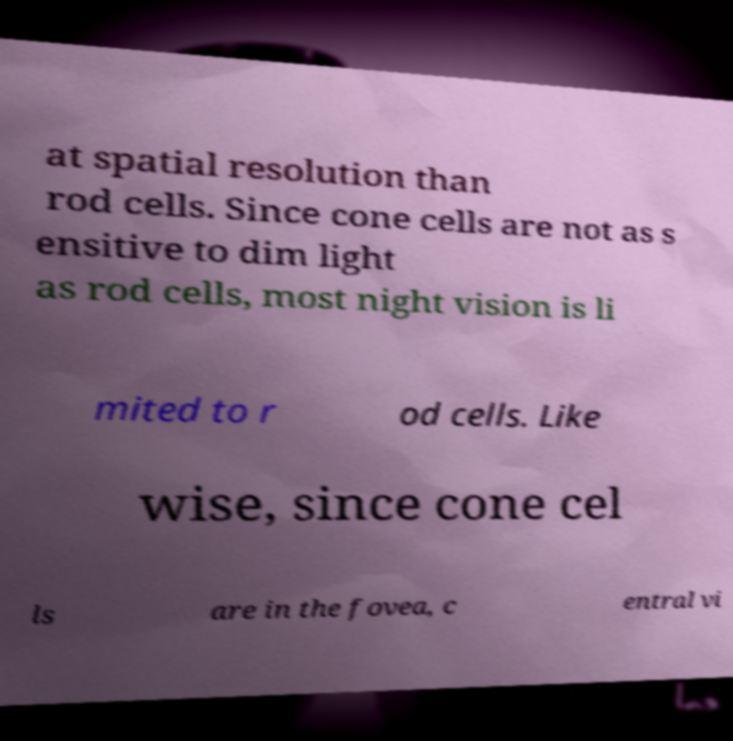Please identify and transcribe the text found in this image. at spatial resolution than rod cells. Since cone cells are not as s ensitive to dim light as rod cells, most night vision is li mited to r od cells. Like wise, since cone cel ls are in the fovea, c entral vi 